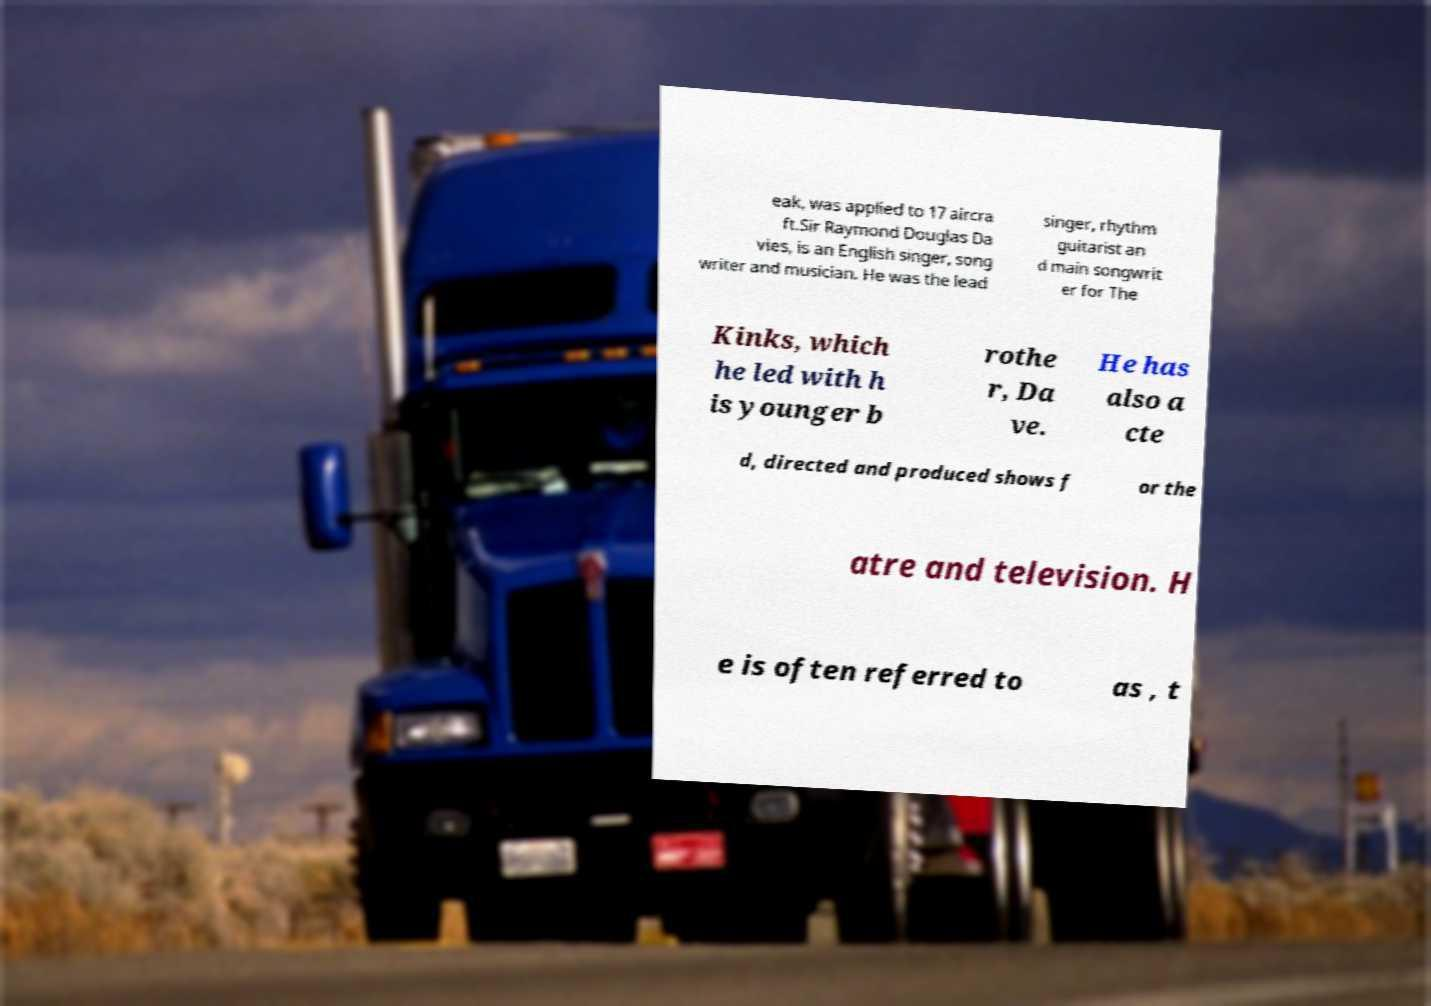Can you accurately transcribe the text from the provided image for me? eak, was applied to 17 aircra ft.Sir Raymond Douglas Da vies, is an English singer, song writer and musician. He was the lead singer, rhythm guitarist an d main songwrit er for The Kinks, which he led with h is younger b rothe r, Da ve. He has also a cte d, directed and produced shows f or the atre and television. H e is often referred to as , t 